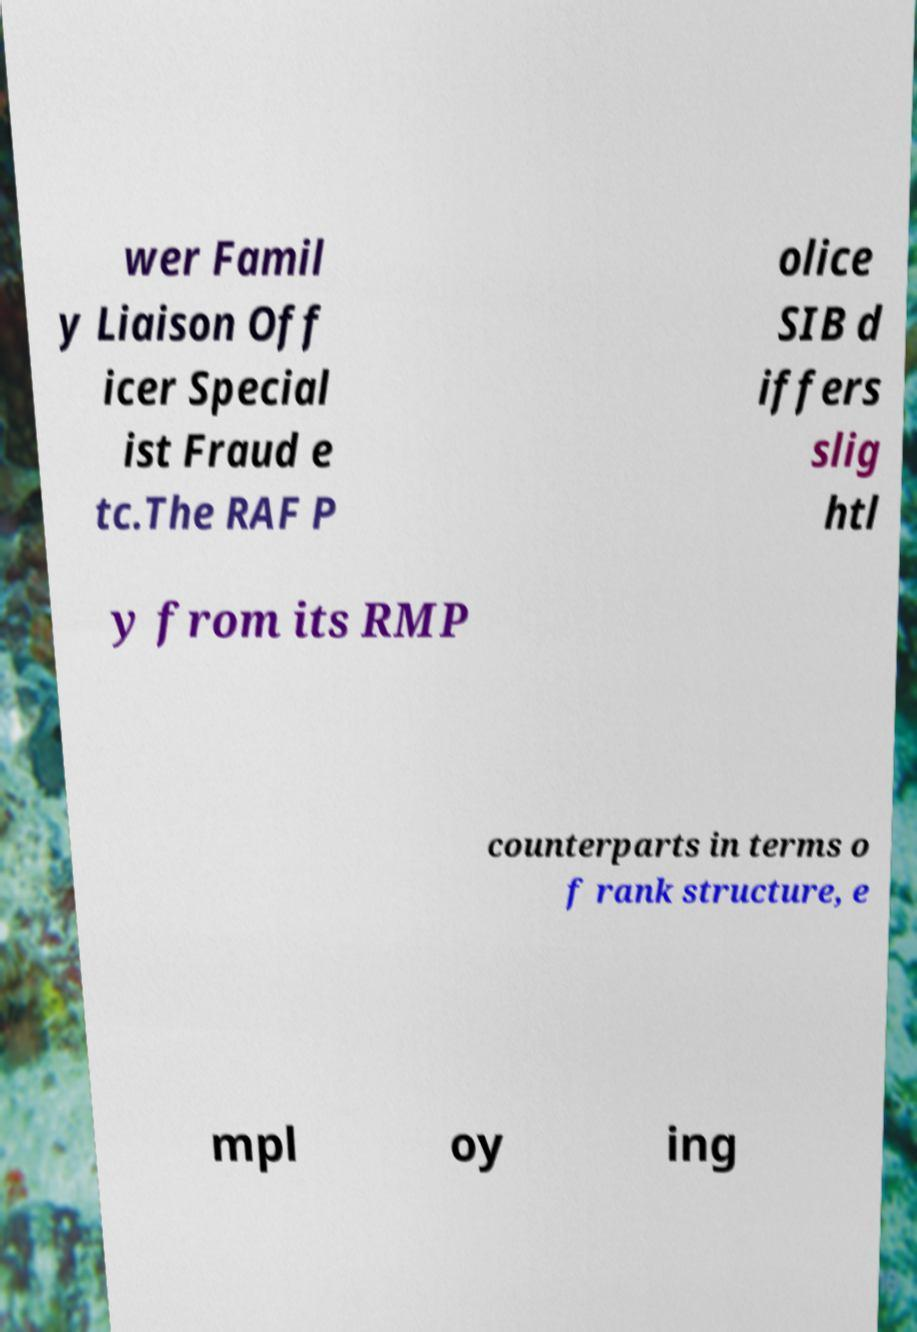Could you extract and type out the text from this image? wer Famil y Liaison Off icer Special ist Fraud e tc.The RAF P olice SIB d iffers slig htl y from its RMP counterparts in terms o f rank structure, e mpl oy ing 